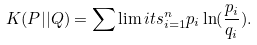<formula> <loc_0><loc_0><loc_500><loc_500>K ( P | | Q ) = \sum \lim i t s _ { i = 1 } ^ { n } { p _ { i } \ln ( \frac { p _ { i } } { q _ { i } } ) } .</formula> 